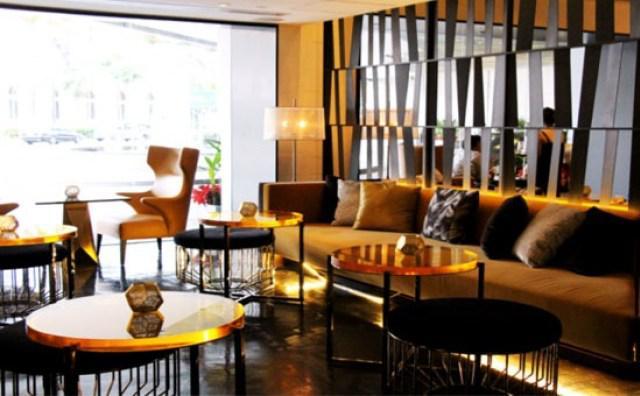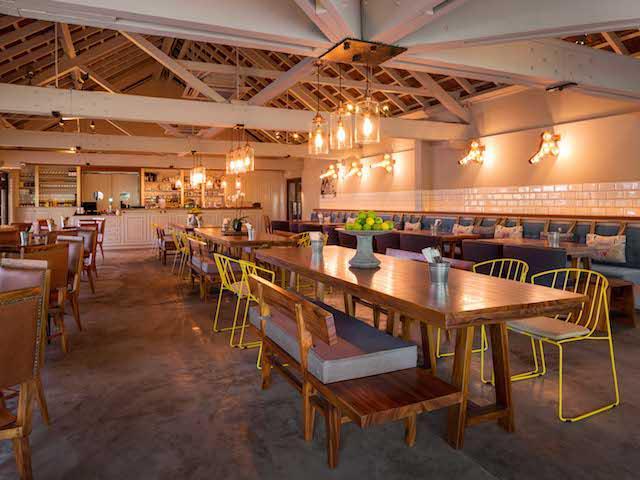The first image is the image on the left, the second image is the image on the right. For the images shown, is this caption "In one image, green things are suspended from the ceiling over a dining area that includes square tables for four." true? Answer yes or no. No. The first image is the image on the left, the second image is the image on the right. Evaluate the accuracy of this statement regarding the images: "Some tables have glass candle holders on them.". Is it true? Answer yes or no. Yes. 